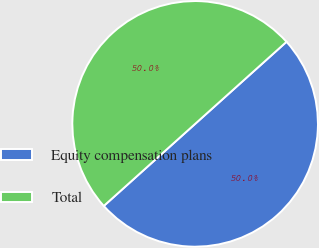<chart> <loc_0><loc_0><loc_500><loc_500><pie_chart><fcel>Equity compensation plans<fcel>Total<nl><fcel>50.0%<fcel>50.0%<nl></chart> 